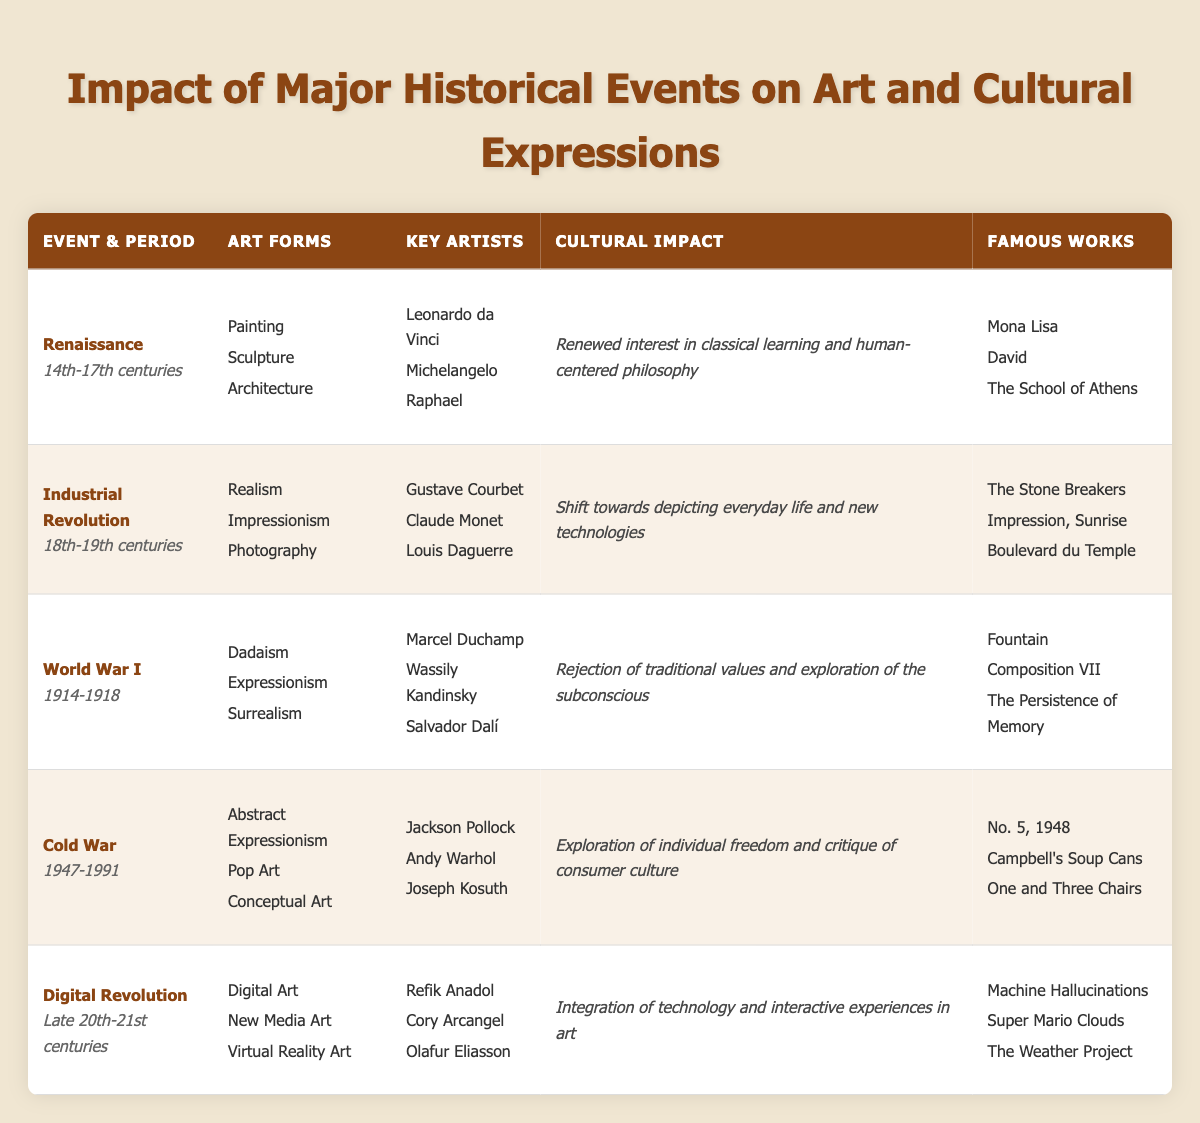What were the key artists of the Renaissance period? The Renaissance period lasted from the 14th to the 17th centuries. The table lists the key artists associated with this event as Leonardo da Vinci, Michelangelo, and Raphael.
Answer: Leonardo da Vinci, Michelangelo, Raphael Which event is related to the art form of Surrealism? The table indicates that Surrealism is associated with World War I, which occurred from 1914 to 1918.
Answer: World War I How many art forms are listed for the Industrial Revolution? The Industrial Revolution includes three art forms: Realism, Impressionism, and Photography. Counting these, we find a total of three art forms listed.
Answer: 3 Was there a cultural impact of the Digital Revolution that involved integrating technology? The cultural impact of the Digital Revolution, as noted in the table, is that it involved the integration of technology and interactive experiences in art. Therefore, the answer is yes.
Answer: Yes Which historical event led to the exploration of individual freedom and critique of consumer culture? The historical event in the table that is associated with the exploration of individual freedom and critique of consumer culture is the Cold War, which lasted from 1947 to 1991.
Answer: Cold War What is the average number of key artists noted for each event? The table lists a total of 15 key artists across 5 historical events (3 artists each for Renaissance, Industrial Revolution, World War I, and Cold War, and 3 for Digital Revolution). To find the average, we calculate 15 key artists divided by 5 events, resulting in 3 key artists per event on average.
Answer: 3 Name a famous work associated with Dadaism. The table shows that "Fountain," created by Marcel Duchamp, is a famous work associated with Dadaism, which emerged during World War I.
Answer: Fountain Which art forms are connected to the Cold War and how many are there? The Cold War is associated with three art forms: Abstract Expressionism, Pop Art, and Conceptual Art, totaling three art forms.
Answer: 3 Did the Renaissance period include the art form of Photography? According to the table, Photography is not listed under the Renaissance period; instead, it belongs to the Industrial Revolution. Therefore, the answer is no.
Answer: No 